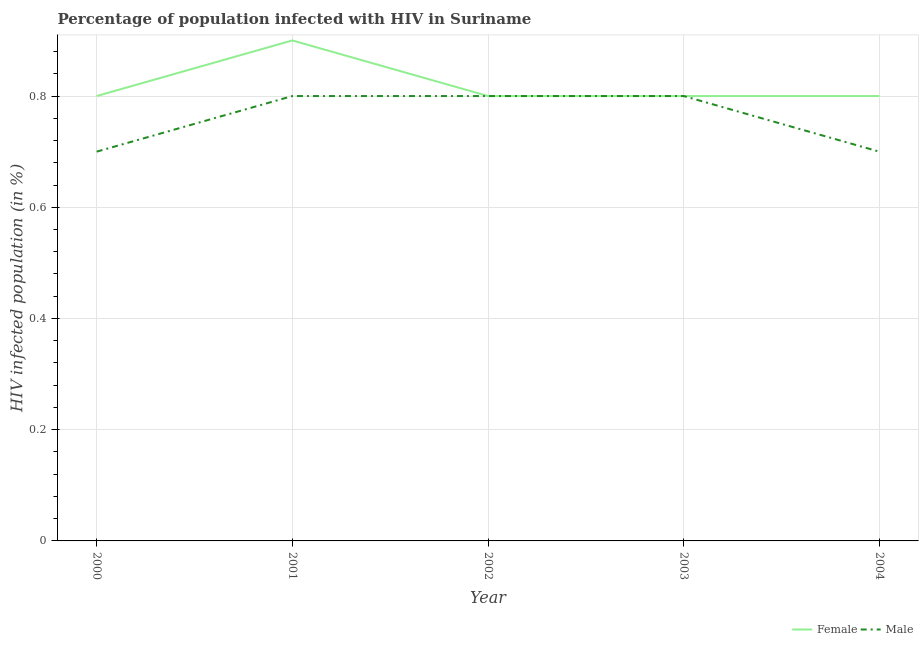How many different coloured lines are there?
Offer a very short reply. 2. Is the number of lines equal to the number of legend labels?
Your answer should be compact. Yes. In which year was the percentage of females who are infected with hiv maximum?
Offer a terse response. 2001. What is the difference between the percentage of males who are infected with hiv in 2000 and that in 2003?
Provide a succinct answer. -0.1. What is the difference between the percentage of females who are infected with hiv in 2002 and the percentage of males who are infected with hiv in 2000?
Your answer should be compact. 0.1. What is the average percentage of females who are infected with hiv per year?
Ensure brevity in your answer.  0.82. In the year 2001, what is the difference between the percentage of males who are infected with hiv and percentage of females who are infected with hiv?
Make the answer very short. -0.1. In how many years, is the percentage of males who are infected with hiv greater than 0.7200000000000001 %?
Offer a terse response. 3. Is the percentage of females who are infected with hiv in 2000 less than that in 2004?
Provide a succinct answer. No. What is the difference between the highest and the second highest percentage of males who are infected with hiv?
Provide a succinct answer. 0. What is the difference between the highest and the lowest percentage of males who are infected with hiv?
Keep it short and to the point. 0.1. Is the sum of the percentage of males who are infected with hiv in 2000 and 2003 greater than the maximum percentage of females who are infected with hiv across all years?
Give a very brief answer. Yes. Is the percentage of females who are infected with hiv strictly greater than the percentage of males who are infected with hiv over the years?
Ensure brevity in your answer.  No. How many lines are there?
Provide a succinct answer. 2. How many years are there in the graph?
Keep it short and to the point. 5. What is the difference between two consecutive major ticks on the Y-axis?
Your response must be concise. 0.2. Does the graph contain any zero values?
Your response must be concise. No. Does the graph contain grids?
Keep it short and to the point. Yes. How many legend labels are there?
Your answer should be very brief. 2. How are the legend labels stacked?
Your response must be concise. Horizontal. What is the title of the graph?
Ensure brevity in your answer.  Percentage of population infected with HIV in Suriname. Does "Registered firms" appear as one of the legend labels in the graph?
Ensure brevity in your answer.  No. What is the label or title of the Y-axis?
Provide a short and direct response. HIV infected population (in %). What is the HIV infected population (in %) in Male in 2000?
Keep it short and to the point. 0.7. What is the HIV infected population (in %) in Male in 2001?
Ensure brevity in your answer.  0.8. What is the HIV infected population (in %) of Female in 2003?
Your answer should be compact. 0.8. What is the HIV infected population (in %) of Female in 2004?
Ensure brevity in your answer.  0.8. What is the HIV infected population (in %) in Male in 2004?
Offer a very short reply. 0.7. Across all years, what is the maximum HIV infected population (in %) of Female?
Your answer should be compact. 0.9. Across all years, what is the maximum HIV infected population (in %) in Male?
Make the answer very short. 0.8. Across all years, what is the minimum HIV infected population (in %) in Female?
Keep it short and to the point. 0.8. What is the total HIV infected population (in %) in Female in the graph?
Offer a terse response. 4.1. What is the difference between the HIV infected population (in %) in Male in 2000 and that in 2001?
Provide a succinct answer. -0.1. What is the difference between the HIV infected population (in %) of Female in 2000 and that in 2002?
Give a very brief answer. 0. What is the difference between the HIV infected population (in %) of Male in 2000 and that in 2002?
Give a very brief answer. -0.1. What is the difference between the HIV infected population (in %) of Female in 2000 and that in 2003?
Your answer should be compact. 0. What is the difference between the HIV infected population (in %) in Male in 2000 and that in 2004?
Make the answer very short. 0. What is the difference between the HIV infected population (in %) of Female in 2001 and that in 2003?
Give a very brief answer. 0.1. What is the difference between the HIV infected population (in %) of Male in 2002 and that in 2003?
Your response must be concise. 0. What is the difference between the HIV infected population (in %) in Female in 2002 and that in 2004?
Provide a succinct answer. 0. What is the difference between the HIV infected population (in %) in Male in 2002 and that in 2004?
Your answer should be very brief. 0.1. What is the difference between the HIV infected population (in %) of Male in 2003 and that in 2004?
Offer a terse response. 0.1. What is the difference between the HIV infected population (in %) in Female in 2000 and the HIV infected population (in %) in Male in 2001?
Your answer should be very brief. 0. What is the difference between the HIV infected population (in %) of Female in 2000 and the HIV infected population (in %) of Male in 2002?
Offer a very short reply. 0. What is the difference between the HIV infected population (in %) in Female in 2001 and the HIV infected population (in %) in Male in 2004?
Offer a very short reply. 0.2. What is the average HIV infected population (in %) in Female per year?
Your answer should be compact. 0.82. What is the average HIV infected population (in %) in Male per year?
Make the answer very short. 0.76. What is the ratio of the HIV infected population (in %) of Female in 2000 to that in 2002?
Make the answer very short. 1. What is the ratio of the HIV infected population (in %) in Male in 2000 to that in 2002?
Offer a very short reply. 0.88. What is the ratio of the HIV infected population (in %) of Male in 2001 to that in 2004?
Give a very brief answer. 1.14. What is the ratio of the HIV infected population (in %) in Female in 2002 to that in 2003?
Provide a succinct answer. 1. What is the ratio of the HIV infected population (in %) of Female in 2002 to that in 2004?
Your answer should be very brief. 1. What is the ratio of the HIV infected population (in %) of Male in 2002 to that in 2004?
Make the answer very short. 1.14. What is the ratio of the HIV infected population (in %) of Female in 2003 to that in 2004?
Your response must be concise. 1. What is the ratio of the HIV infected population (in %) in Male in 2003 to that in 2004?
Provide a succinct answer. 1.14. What is the difference between the highest and the second highest HIV infected population (in %) in Male?
Offer a terse response. 0. What is the difference between the highest and the lowest HIV infected population (in %) of Male?
Your response must be concise. 0.1. 